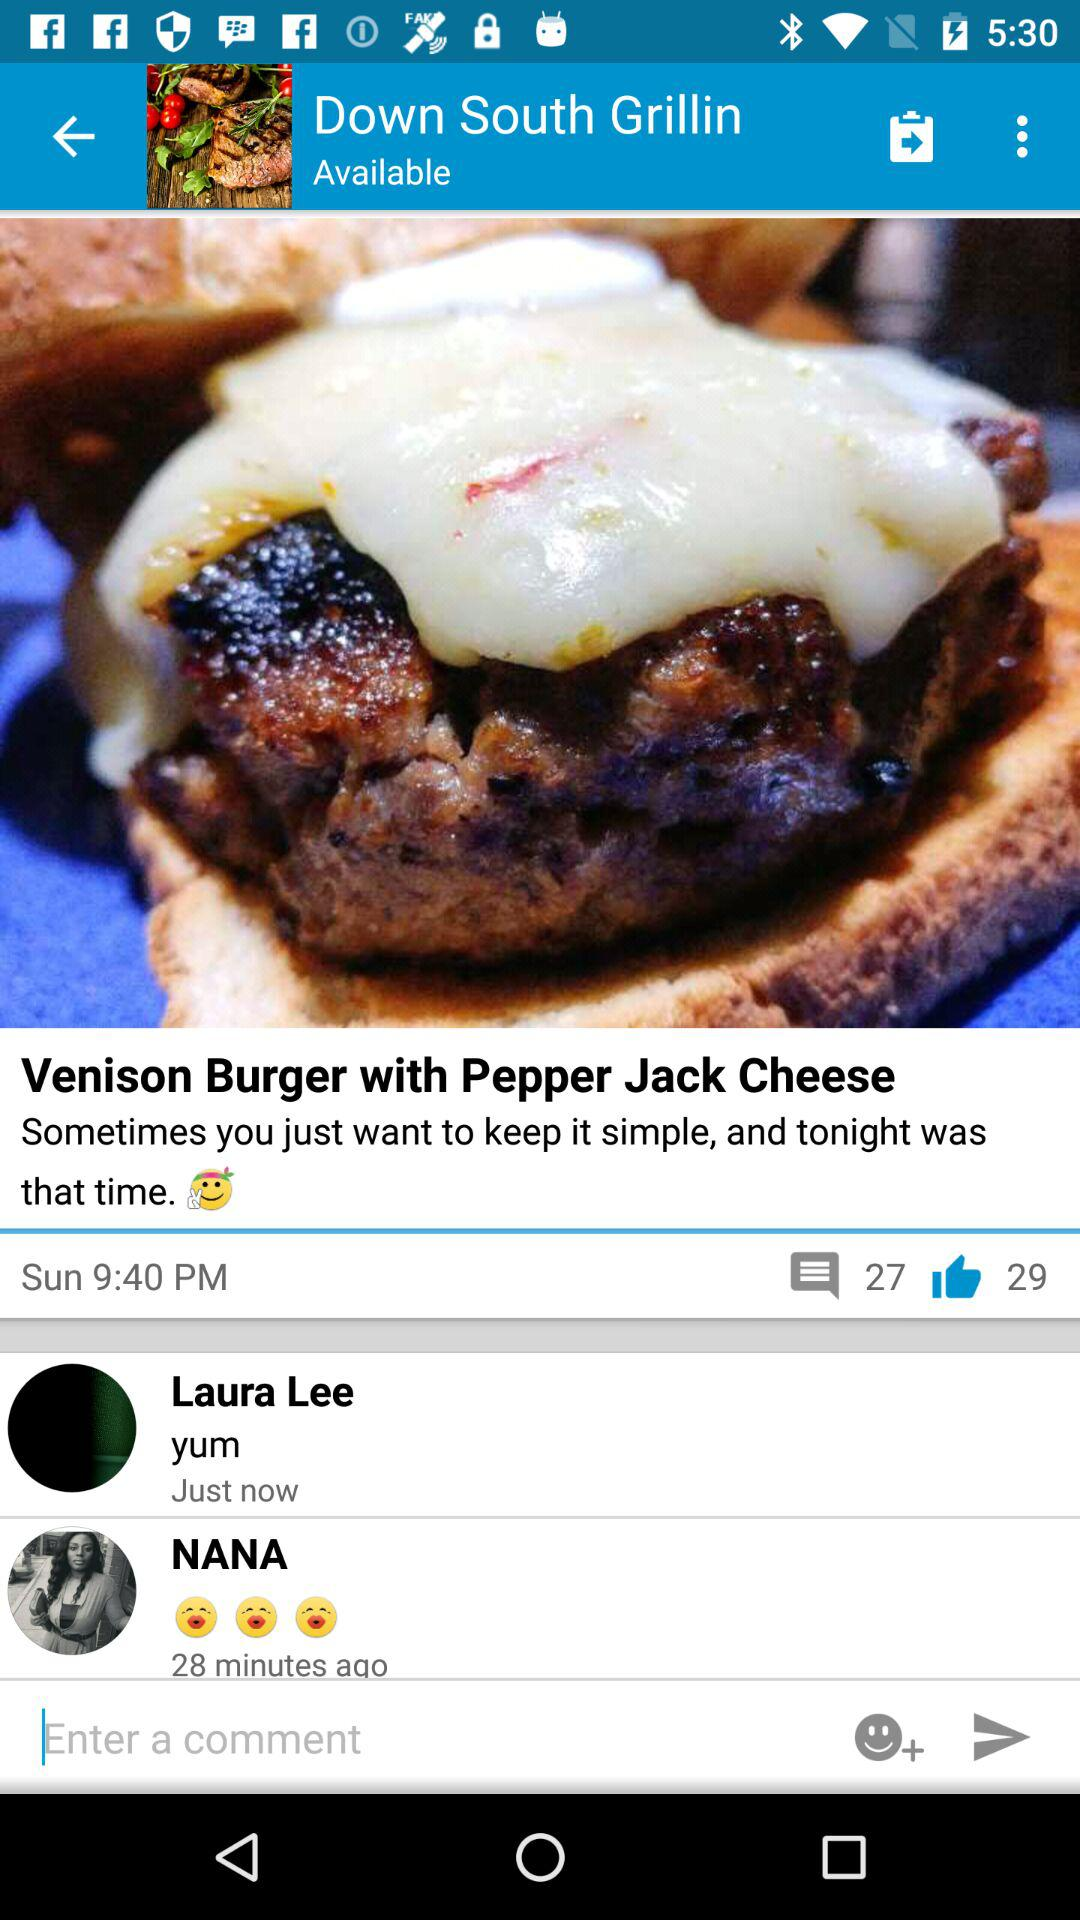When was the "Venison Burger with Pepper Jack Cheese" posted? The "Venison Burger with Pepper Jack Cheese" was posted on Sunday at 9:40 PM. 